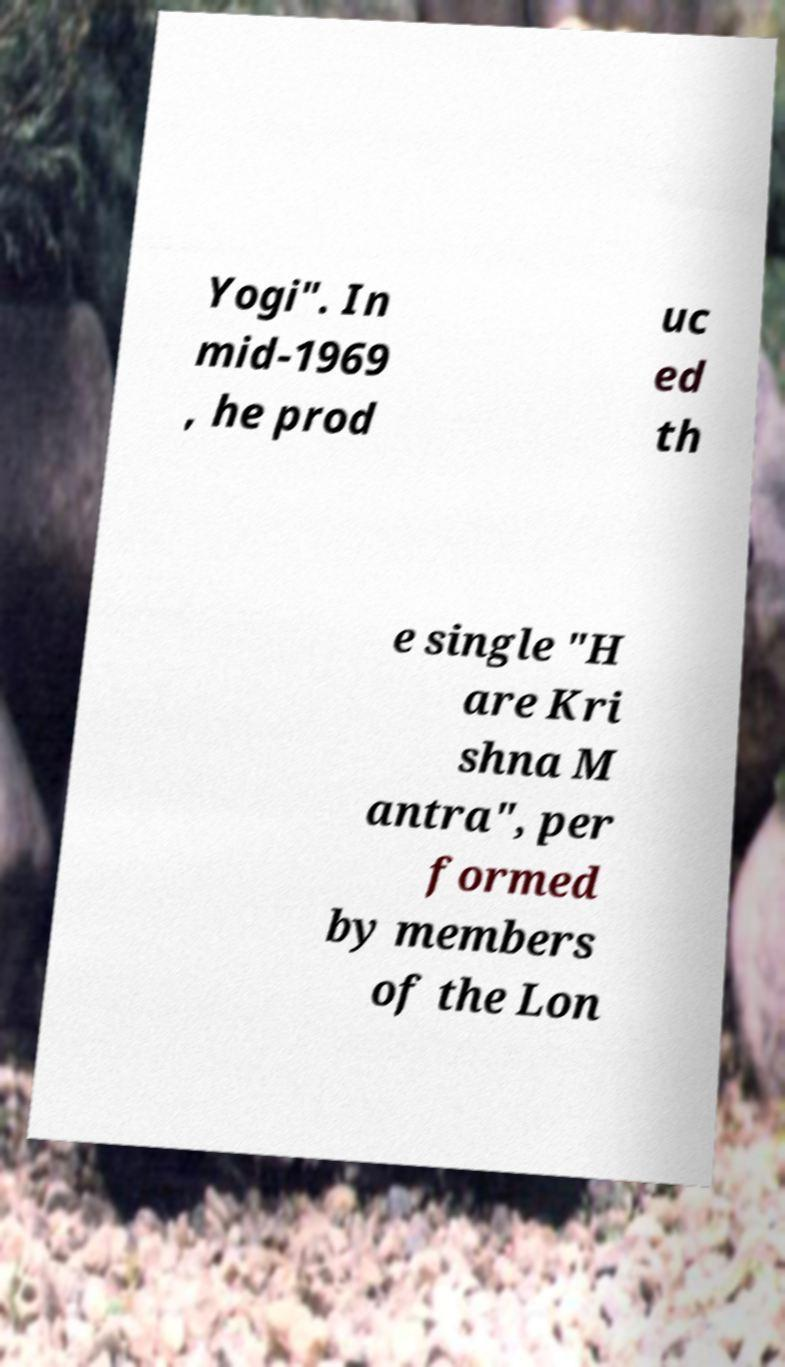I need the written content from this picture converted into text. Can you do that? Yogi". In mid-1969 , he prod uc ed th e single "H are Kri shna M antra", per formed by members of the Lon 